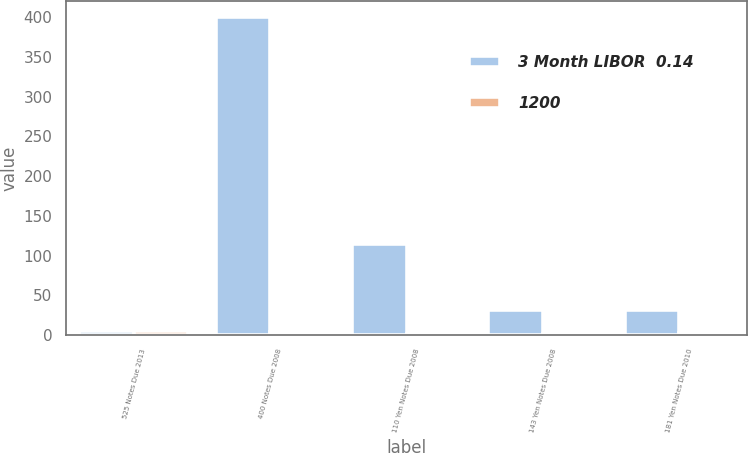<chart> <loc_0><loc_0><loc_500><loc_500><stacked_bar_chart><ecel><fcel>525 Notes Due 2013<fcel>400 Notes Due 2008<fcel>110 Yen Notes Due 2008<fcel>143 Yen Notes Due 2008<fcel>181 Yen Notes Due 2010<nl><fcel>3 Month LIBOR  0.14<fcel>5.47<fcel>400<fcel>114<fcel>32<fcel>32<nl><fcel>1200<fcel>5.47<fcel>4.19<fcel>1.33<fcel>1.59<fcel>1.94<nl></chart> 